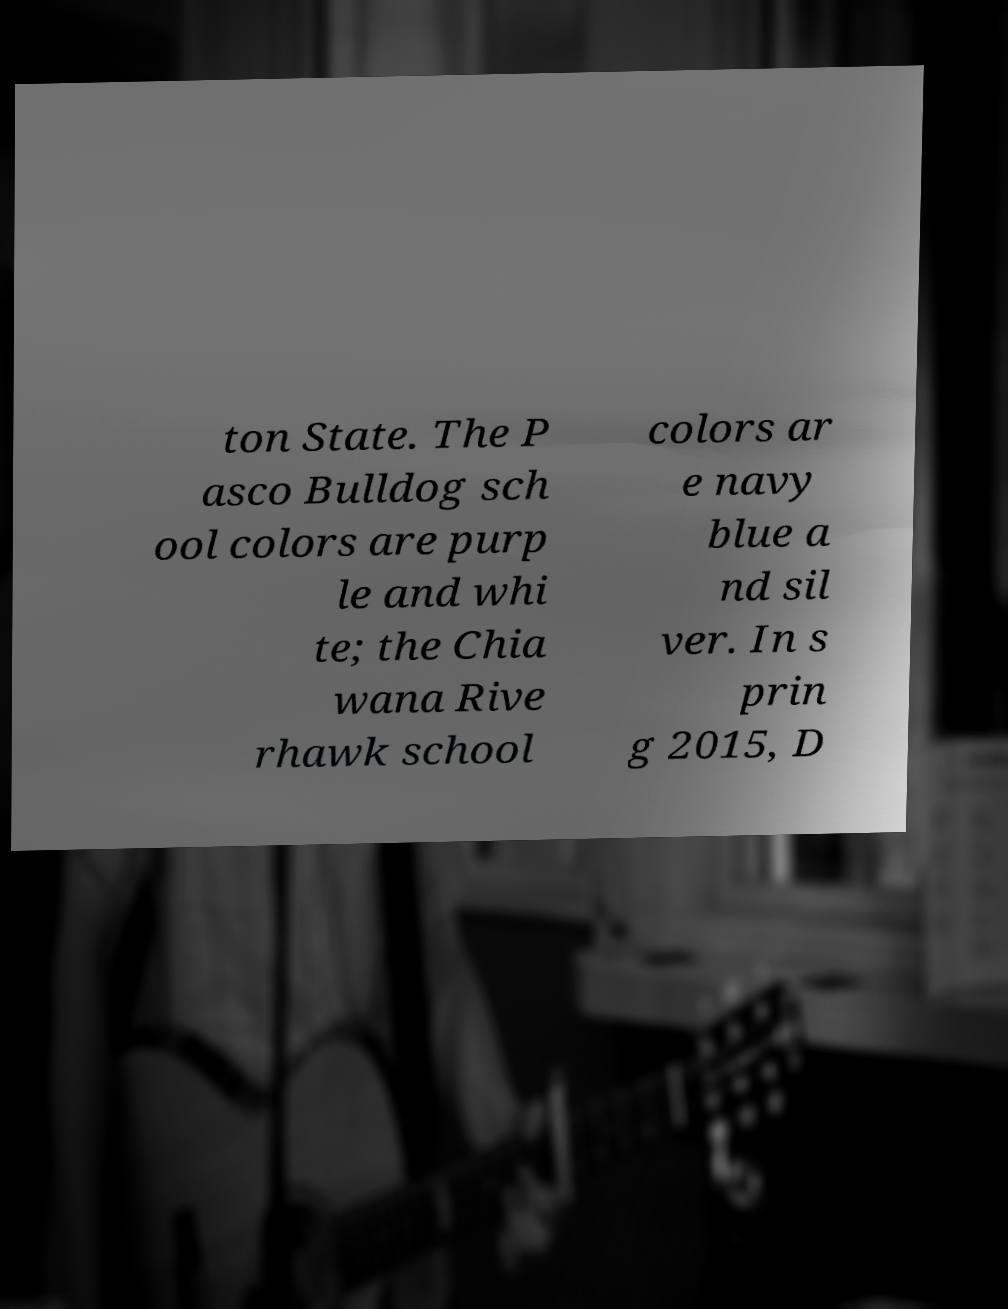There's text embedded in this image that I need extracted. Can you transcribe it verbatim? ton State. The P asco Bulldog sch ool colors are purp le and whi te; the Chia wana Rive rhawk school colors ar e navy blue a nd sil ver. In s prin g 2015, D 